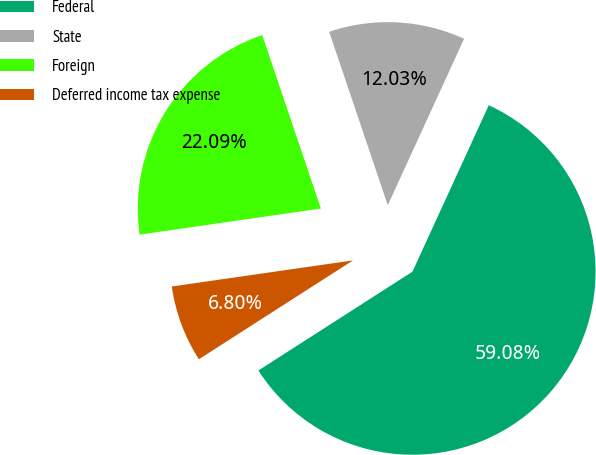<chart> <loc_0><loc_0><loc_500><loc_500><pie_chart><fcel>Federal<fcel>State<fcel>Foreign<fcel>Deferred income tax expense<nl><fcel>59.08%<fcel>12.03%<fcel>22.09%<fcel>6.8%<nl></chart> 